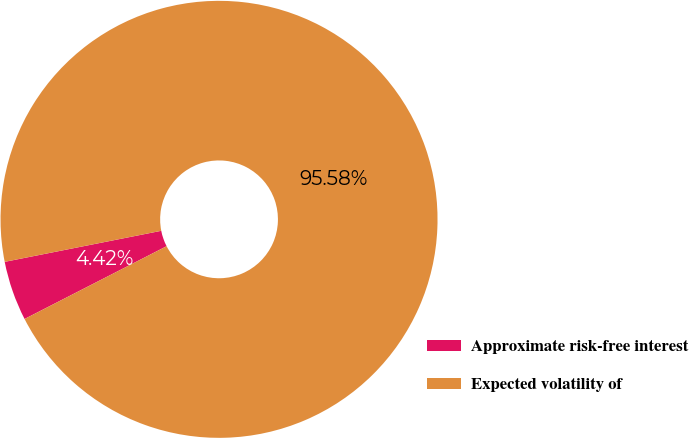Convert chart. <chart><loc_0><loc_0><loc_500><loc_500><pie_chart><fcel>Approximate risk-free interest<fcel>Expected volatility of<nl><fcel>4.42%<fcel>95.58%<nl></chart> 